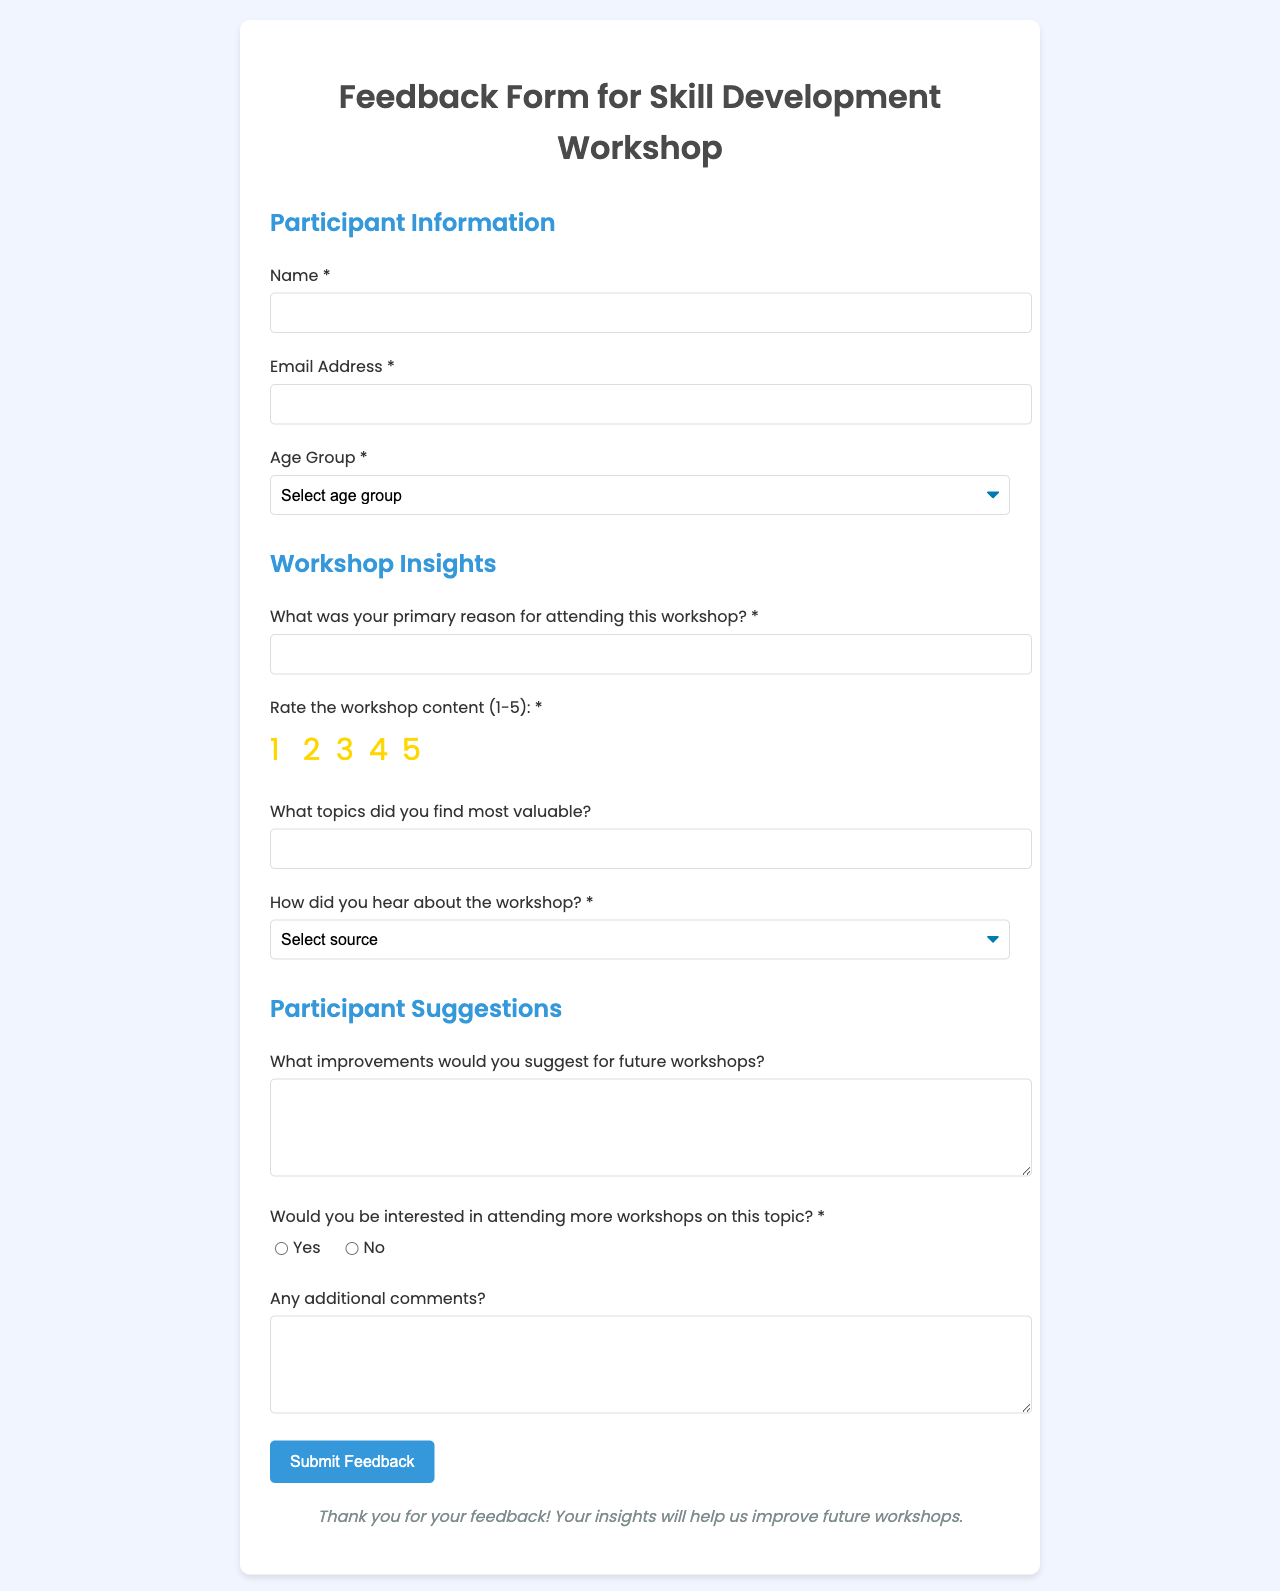What is the title of the document? The title of the document is stated in the title tag of the HTML, which is meant to inform users about the form's purpose.
Answer: Feedback Form for Skill Development Workshop How many age groups are available in the form? The number of options provided in the age group selection helps understand the demographics targeted by the workshop.
Answer: Four What is the rating scale for the workshop content? The rating scale is indicated by the options presented under workshop content, indicating how participants can evaluate their experience.
Answer: 1-5 What is one way participants can provide feedback on future workshops? The feedback form includes a section specifically for participants to suggest improvements for future workshops, addressing their direct concerns.
Answer: Improvements How can participants indicate their interest in attending more workshops? This is indicated by the radio buttons which allow participants to select between yes or no regarding future workshop attendance.
Answer: Yes or No 